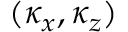<formula> <loc_0><loc_0><loc_500><loc_500>( \kappa _ { x } , \kappa _ { z } )</formula> 